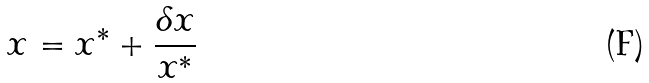Convert formula to latex. <formula><loc_0><loc_0><loc_500><loc_500>x = x ^ { * } + \frac { \delta x } { x ^ { * } }</formula> 